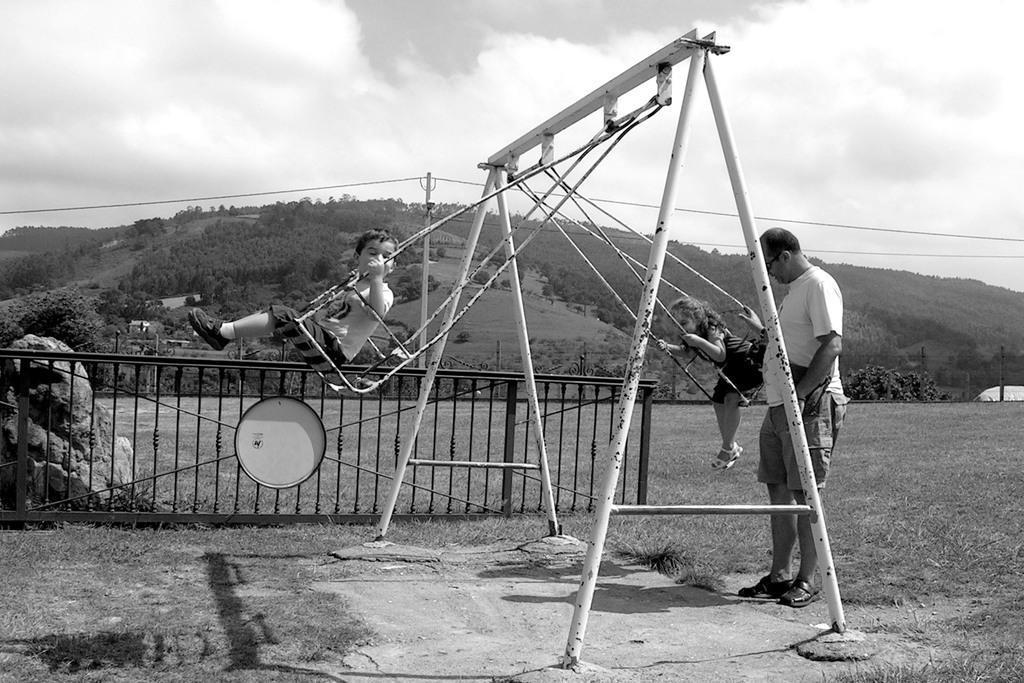Can you describe this image briefly? In this picture I can see 2 swings in front, on which there 2 children sitting and behind the swings I can see a man who is standing and these swings are attached to the rods. In the middle of this picture I can see the railing and the grass. In the background I can see few trees and the sky which is a bit cloudy. 